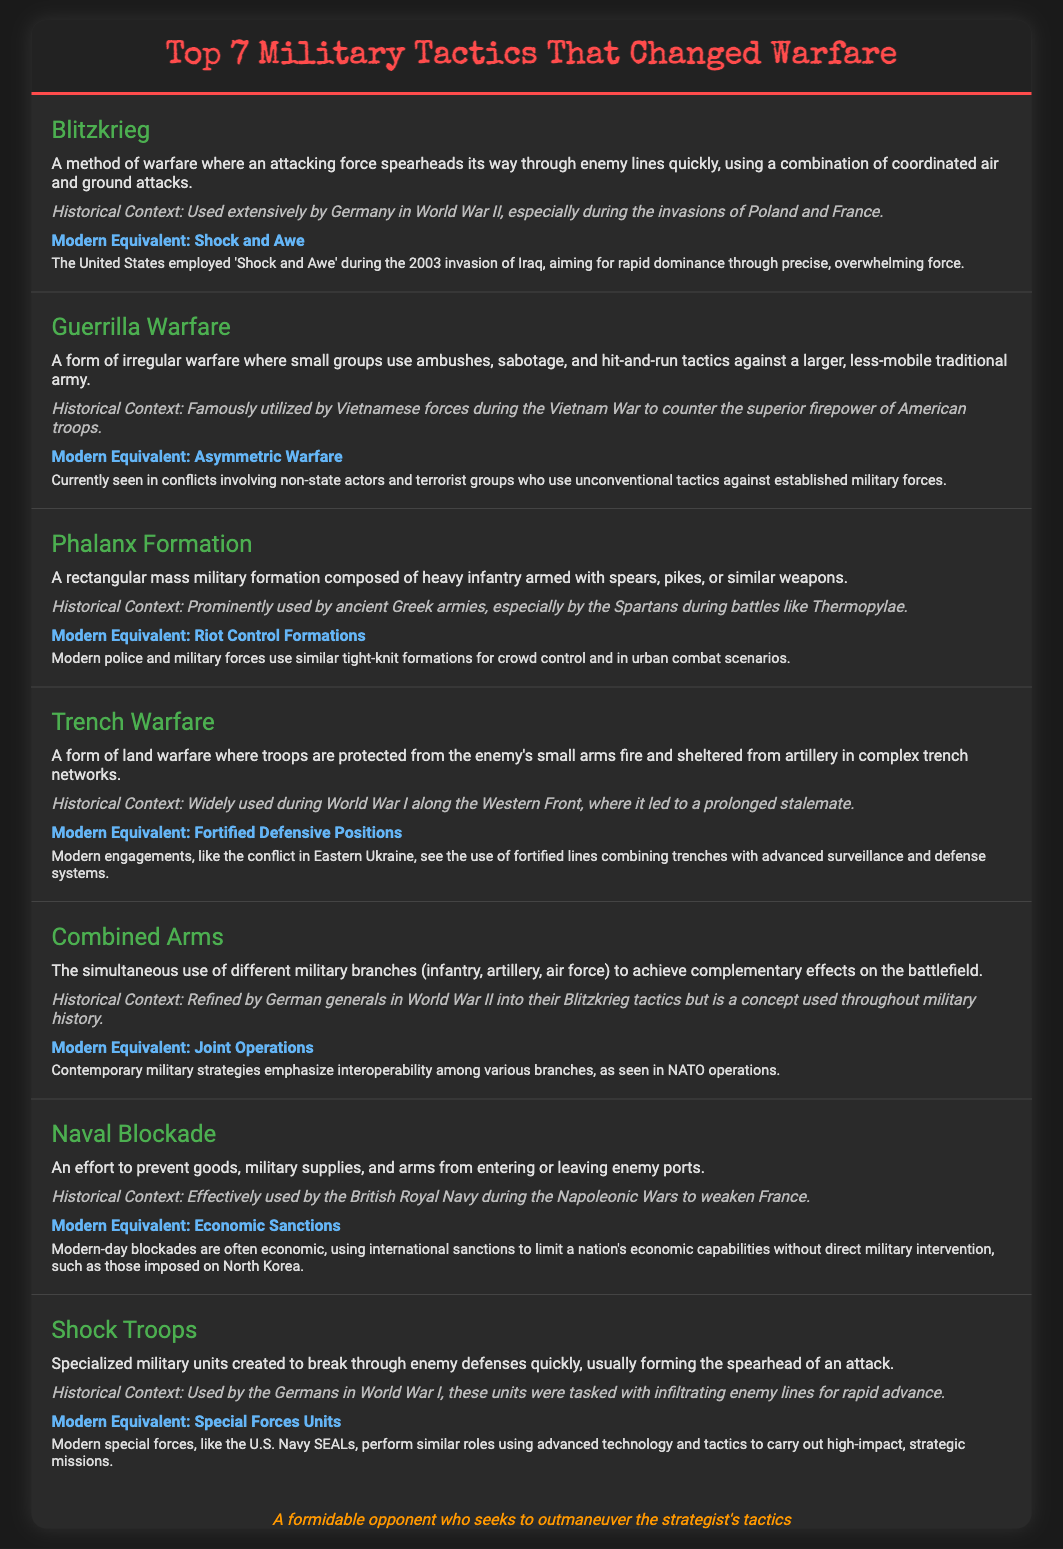what is the first tactic listed? The first tactic listed in the infographic is "Blitzkrieg."
Answer: Blitzkrieg what historical context is associated with Guerrilla Warfare? The historical context associated with Guerrilla Warfare is its use by Vietnamese forces during the Vietnam War.
Answer: Vietnam War which modern equivalent is linked to Trench Warfare? The modern equivalent linked to Trench Warfare is "Fortified Defensive Positions."
Answer: Fortified Defensive Positions how many tactics are covered in the document? The document covers a total of seven military tactics.
Answer: seven what tactic uses "shock and awe" in modern warfare? The tactic that uses "shock and awe" is Blitzkrieg.
Answer: Blitzkrieg what type of military formation is related to the Phalanx Formation? The Phalanx Formation is related to a "rectangular mass military formation."
Answer: rectangular mass military formation what term describes modern operations that emphasize interoperability among military branches? The term that describes this is "Joint Operations."
Answer: Joint Operations 